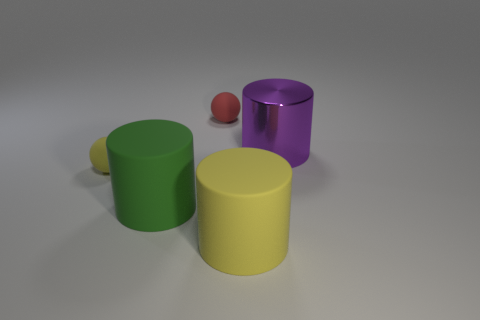What number of red matte balls are there?
Provide a short and direct response. 1. The big thing behind the tiny matte ball on the left side of the red sphere is made of what material?
Ensure brevity in your answer.  Metal. There is a big cylinder that is made of the same material as the big green object; what is its color?
Your answer should be compact. Yellow. There is a yellow cylinder on the left side of the big purple metal cylinder; is it the same size as the cylinder to the left of the large yellow rubber cylinder?
Provide a succinct answer. Yes. What number of balls are tiny yellow objects or brown metal objects?
Your response must be concise. 1. Is the small ball in front of the red object made of the same material as the big purple thing?
Make the answer very short. No. What number of other objects are the same size as the yellow rubber ball?
Provide a succinct answer. 1. How many small things are either red cylinders or rubber things?
Make the answer very short. 2. Are there more large green objects that are to the left of the red rubber thing than large purple shiny things in front of the yellow matte sphere?
Ensure brevity in your answer.  Yes. Is the number of objects that are in front of the purple object greater than the number of yellow blocks?
Your answer should be very brief. Yes. 